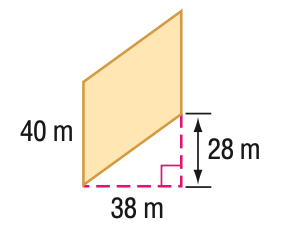Answer the mathemtical geometry problem and directly provide the correct option letter.
Question: Find the area of the parallelogram. Round to the nearest tenth if necessary.
Choices: A: 1064 B: 1120 C: 1520 D: 1888.1 C 